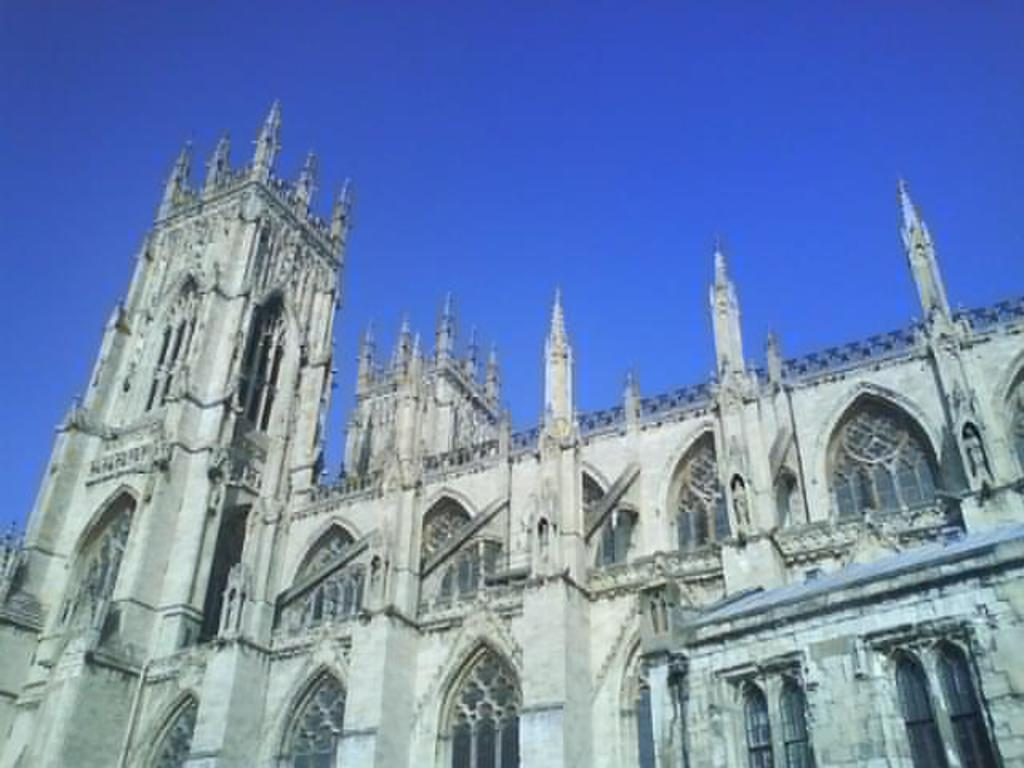What type of structure is present in the image? There is a building in the image. What can be seen in the background of the image? The sky is visible in the background of the image. What message is written on the sign in the image? There is no sign present in the image, so no message can be read. 